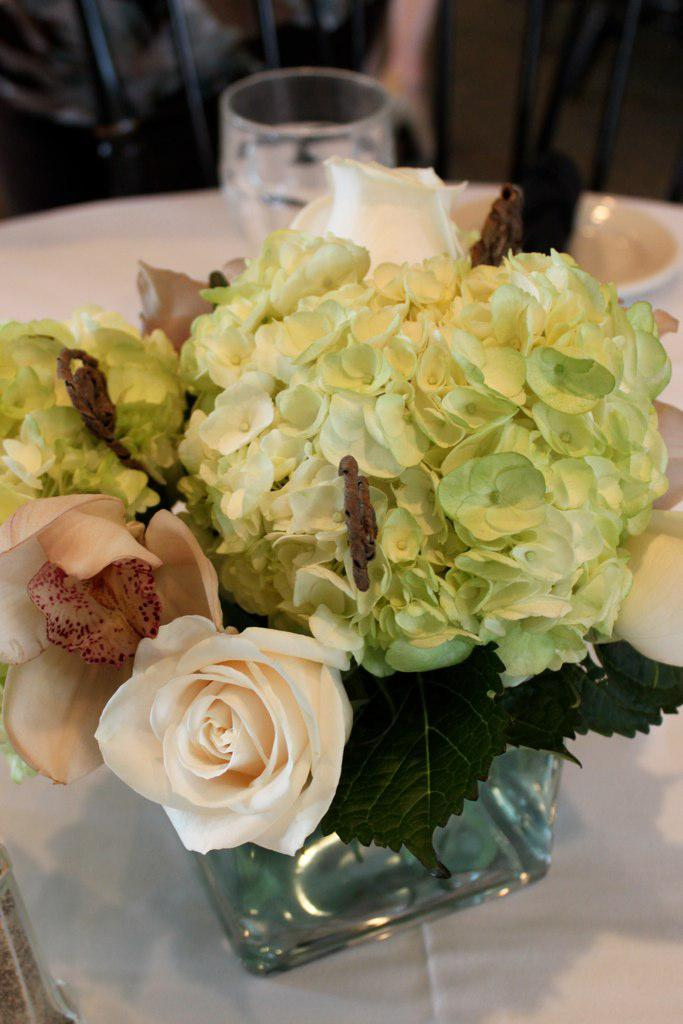What is contained in the glass jar in the image? There are flowers in a glass jar in the image. What type of glassware is visible in the image? There is a wine glass in the image. What else can be seen on the table in the image? There are other things on the table in the image, but their specific details are not mentioned in the provided facts. What type of quartz can be seen in the image? There is no quartz present in the image. What season is depicted in the image? The provided facts do not mention any seasonal details, so it cannot be determined from the image. 